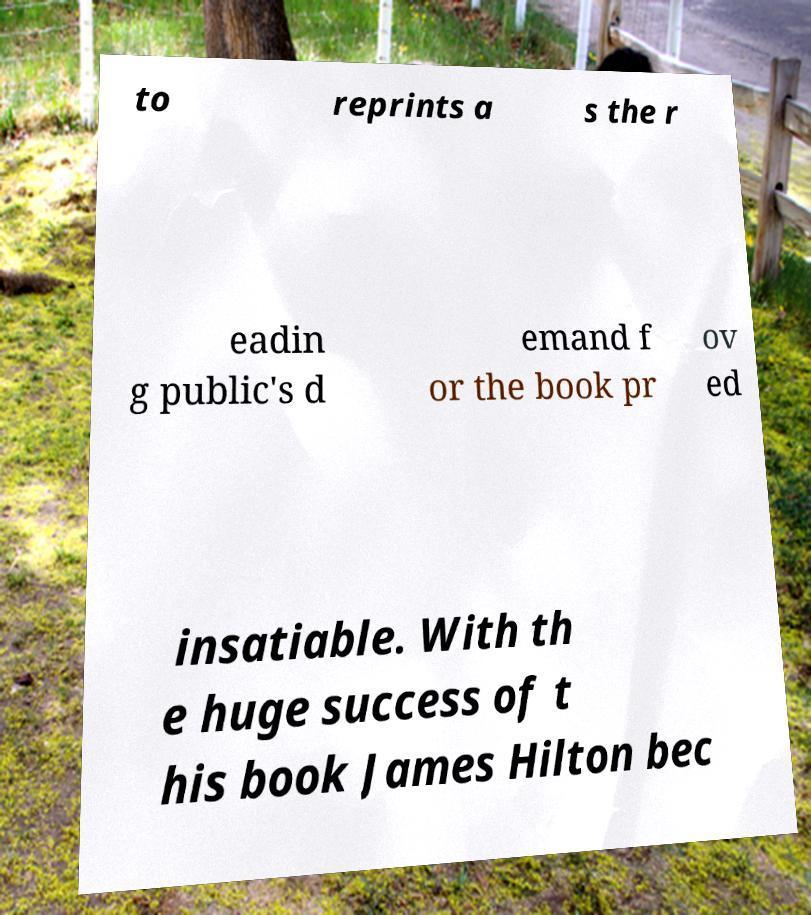Can you accurately transcribe the text from the provided image for me? to reprints a s the r eadin g public's d emand f or the book pr ov ed insatiable. With th e huge success of t his book James Hilton bec 